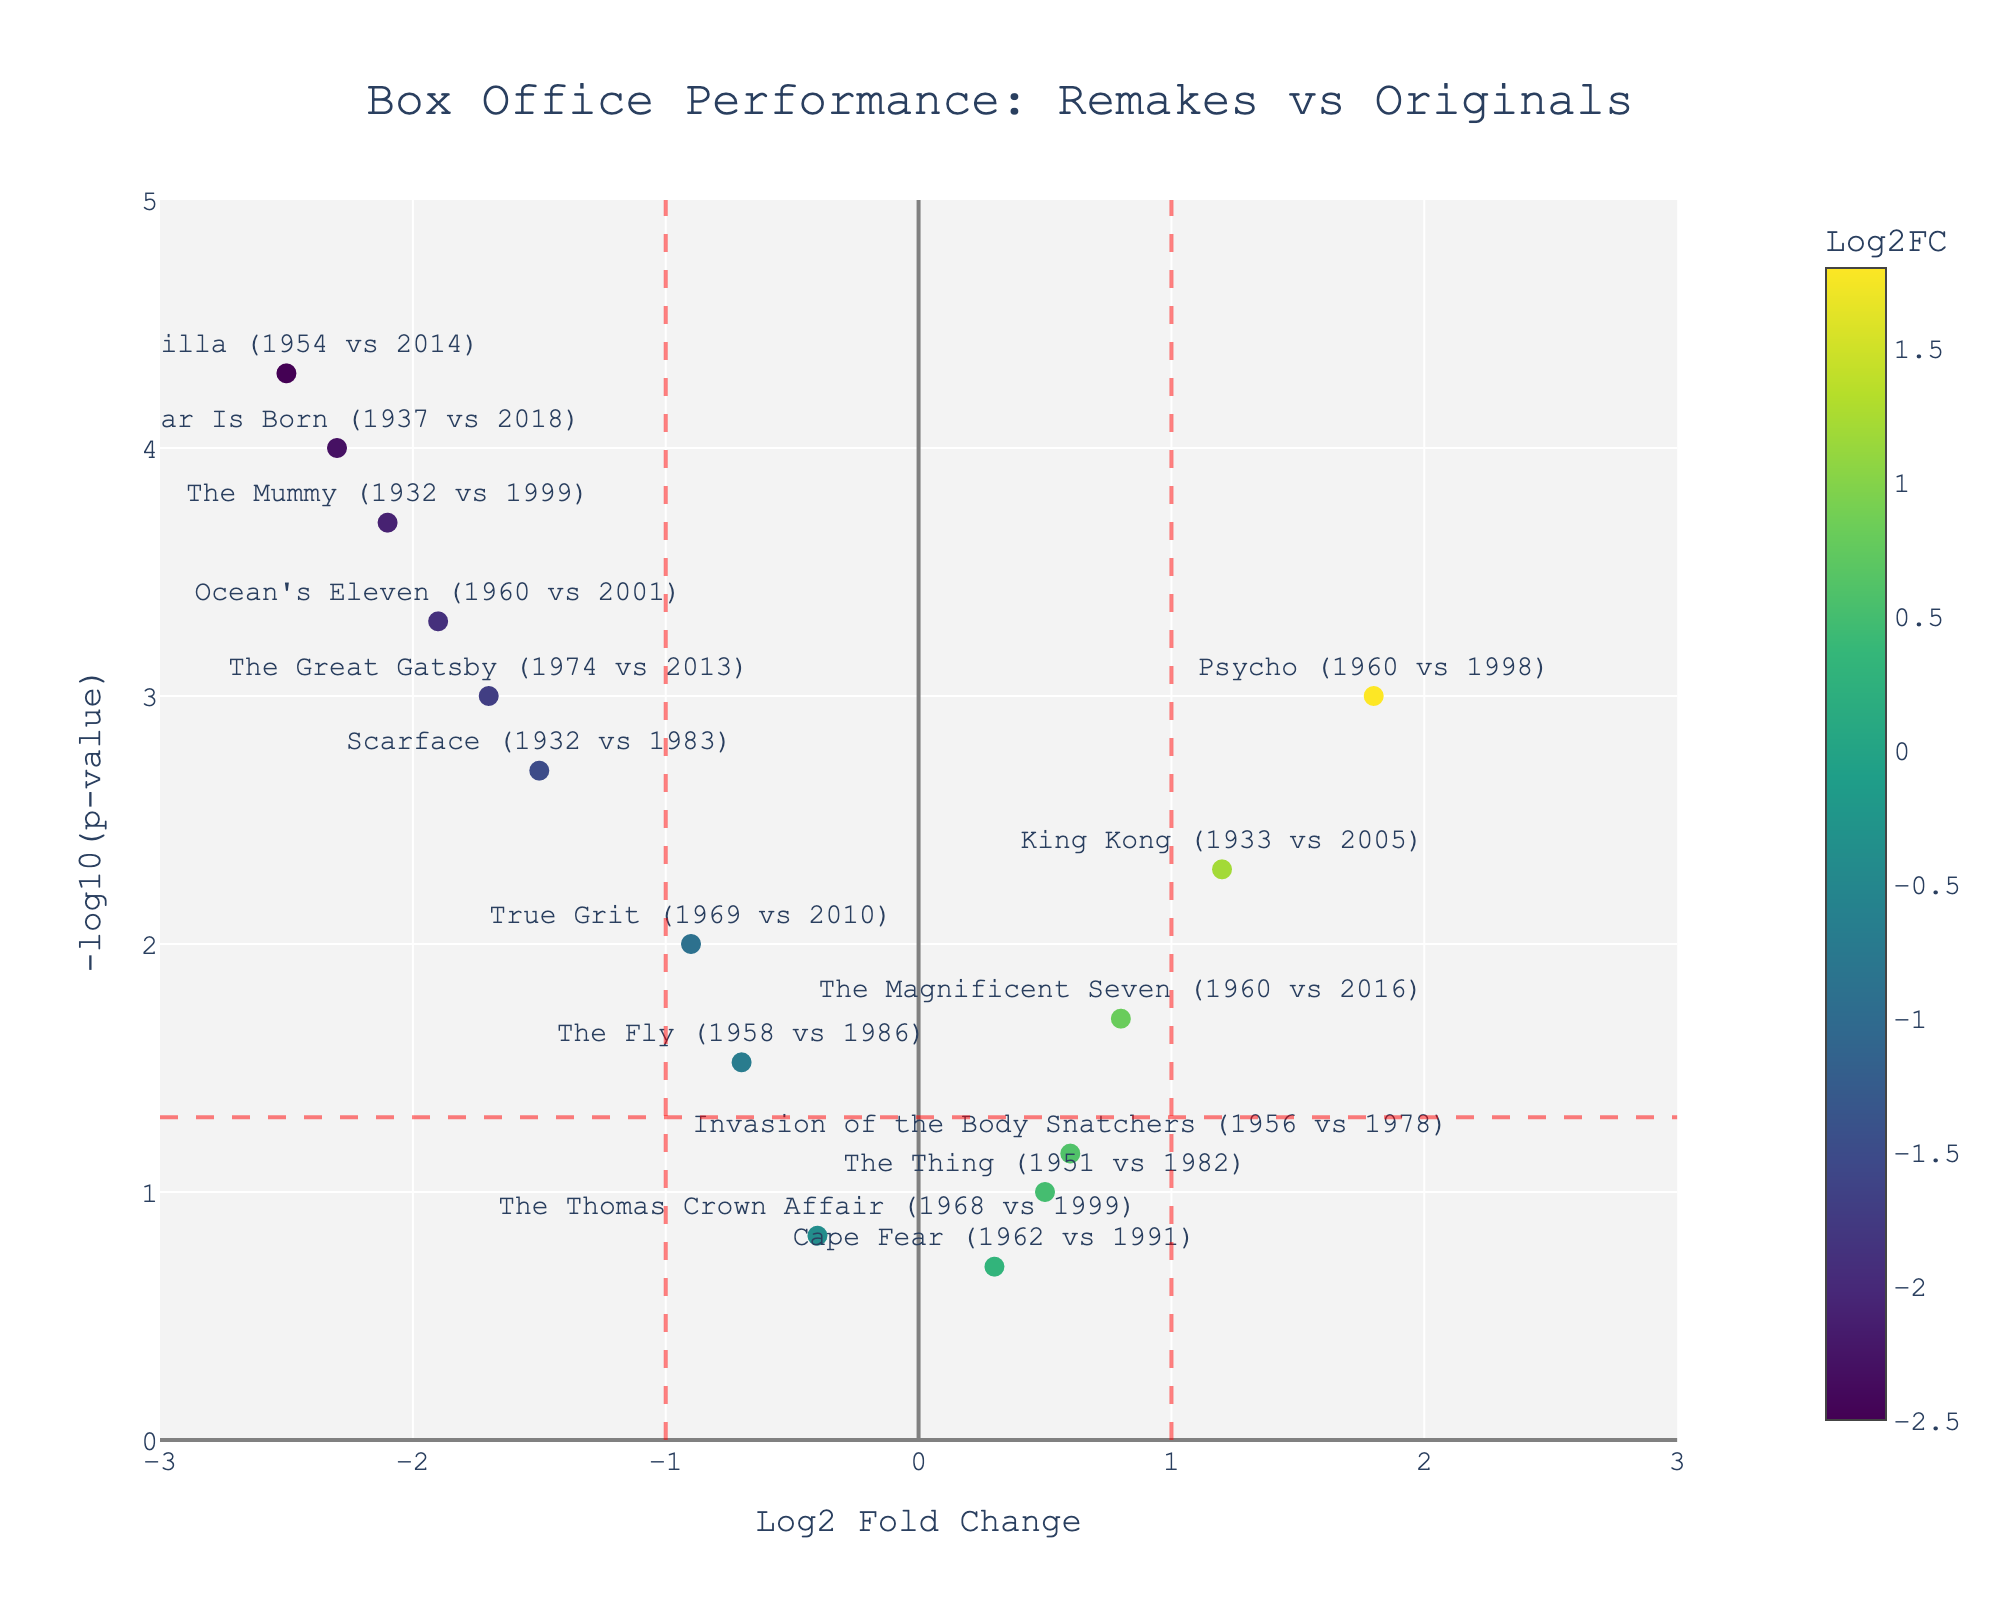What is the title of the plot? The title of the plot is shown at the top center of the figure. It reads "Box Office Performance: Remakes vs Originals".
Answer: Box Office Performance: Remakes vs Originals What do the x-axis and y-axis represent? The x-axis represents the Log2 Fold Change, which measures the ratio of box office performance between remakes and original classic films. The y-axis represents -log10(p-value), indicating the significance of the observed differences.
Answer: x-axis: Log2 Fold Change, y-axis: -log10(p-value) How many movies have a Log2 Fold Change greater than 1? To determine how many movies have a Log2FC greater than 1, identify the data points to the right of the vertical line at x=1. These movies include "Psycho (1960 vs 1998)" and "King Kong (1933 vs 2005)".
Answer: Two Which remake has the most significant p-value compared to its original? The most significant p-value will appear at the top of the y-axis. "Godzilla (1954 vs 2014)" has the highest value of -log10(p-value), indicating the most significant p-value.
Answer: Godzilla (1954 vs 2014) Which movie remake outperformed its original by the highest Log2 Fold Change? The movie with the highest Log2FC is the data point furthest to the right on the x-axis. This is "Psycho (1960 vs 1998)" with a Log2FC of 1.8.
Answer: Psycho (1960 vs 1998) How many movies have p-values less than 0.05? To find movies with p-values less than 0.05, look for points above the horizontal red dashed line. Counting these points gives us: "Psycho (1960 vs 1998)", "A Star Is Born (1937 vs 2018)", "King Kong (1933 vs 2005)", "Scarface (1932 vs 1983)", "Ocean's Eleven (1960 vs 2001)", "The Magnificent Seven (1960 vs 2016)", "True Grit (1969 vs 2010)", "The Mummy (1932 vs 1999)", "The Great Gatsby (1974 vs 2013)", and "Godzilla (1954 vs 2014)".
Answer: Ten Which movie remakes generated less box office revenue than their originals? Negative Log2FC values indicate that remakes generated less revenue than originals. Identifying all points with negative Log2FC gives: "The Fly (1958 vs 1986)", "A Star Is Born (1937 vs 2018)", "Scarface (1932 vs 1983)", "Ocean's Eleven (1960 vs 2001)", "True Grit (1969 vs 2010)", "The Mummy (1932 vs 1999)", "The Great Gatsby (1974 vs 2013)", and "Godzilla (1954 vs 2014)".
Answer: Eight Which movie among the remakes has the lowest significance level? The lowest significance level corresponds to the smallest -log10(p-value). This data point would be the lowest on the y-axis. "Cape Fear (1962 vs 1991)" has the smallest -log10(p-value).
Answer: Cape Fear (1962 vs 1991) Name the movies whose remakes have performed significantly differently (p-value < 0.05) compared to their originals. Identifying movies with p-values less than 0.05 (points above the red dashed line on the y-axis) we have: "Psycho (1960 vs 1998)", "A Star Is Born (1937 vs 2018)", "King Kong (1933 vs 2005)", "Scarface (1932 vs 1983)", "Ocean's Eleven (1960 vs 2001)", "The Magnificent Seven (1960 vs 2016)", "True Grit (1969 vs 2010)", "The Mummy (1932 vs 1999)", "The Great Gatsby (1974 vs 2013)", and "Godzilla (1954 vs 2014)".
Answer: Ten 